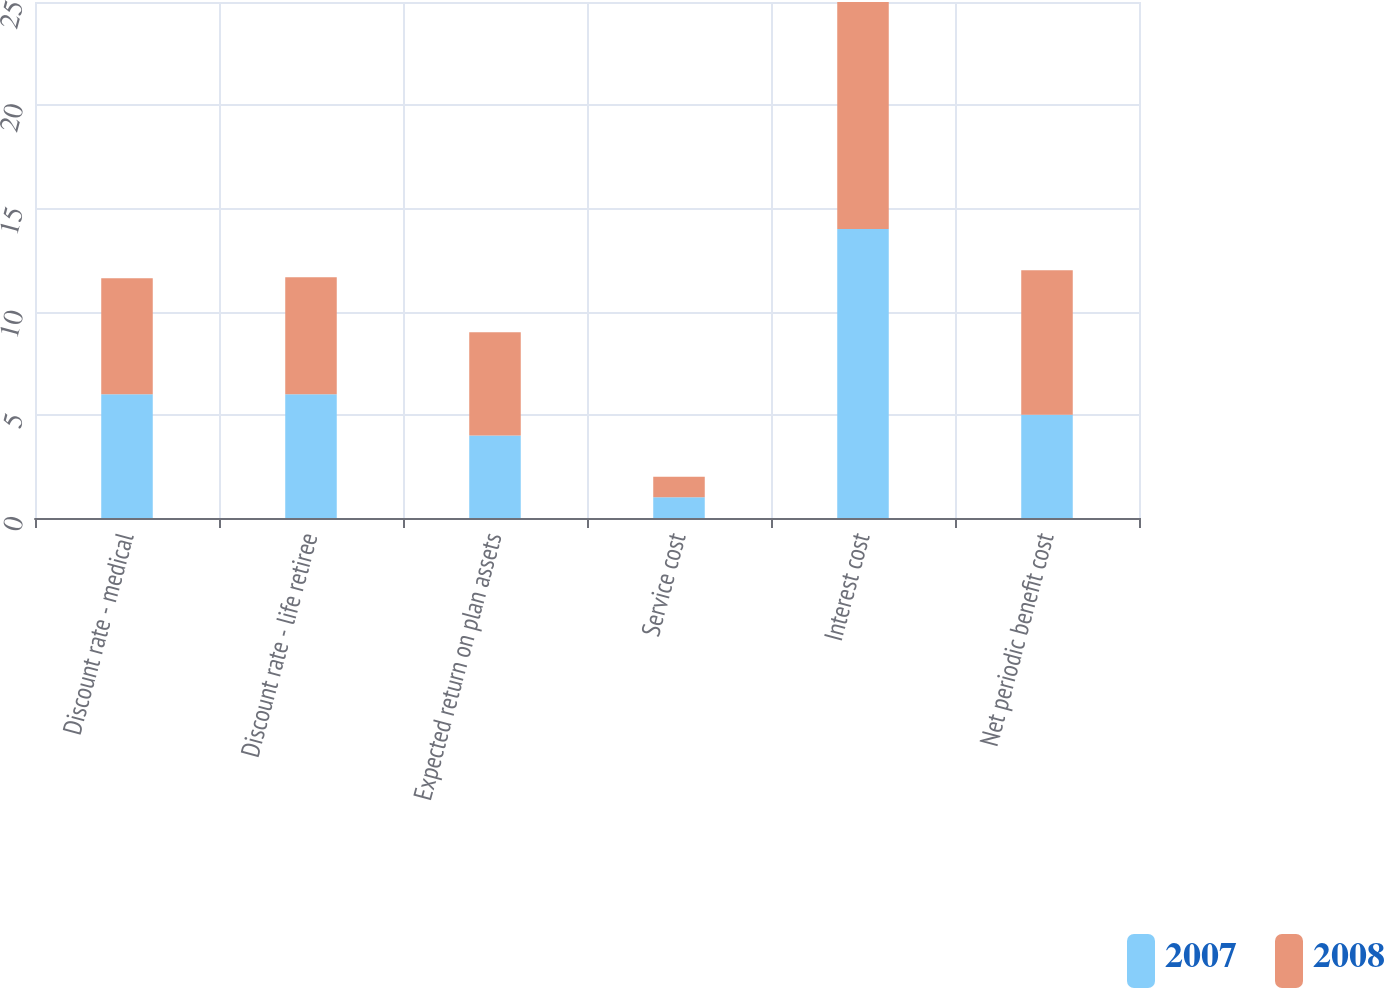<chart> <loc_0><loc_0><loc_500><loc_500><stacked_bar_chart><ecel><fcel>Discount rate - medical<fcel>Discount rate - life retiree<fcel>Expected return on plan assets<fcel>Service cost<fcel>Interest cost<fcel>Net periodic benefit cost<nl><fcel>2007<fcel>6<fcel>6<fcel>4<fcel>1<fcel>14<fcel>5<nl><fcel>2008<fcel>5.62<fcel>5.66<fcel>5<fcel>1<fcel>11<fcel>7<nl></chart> 